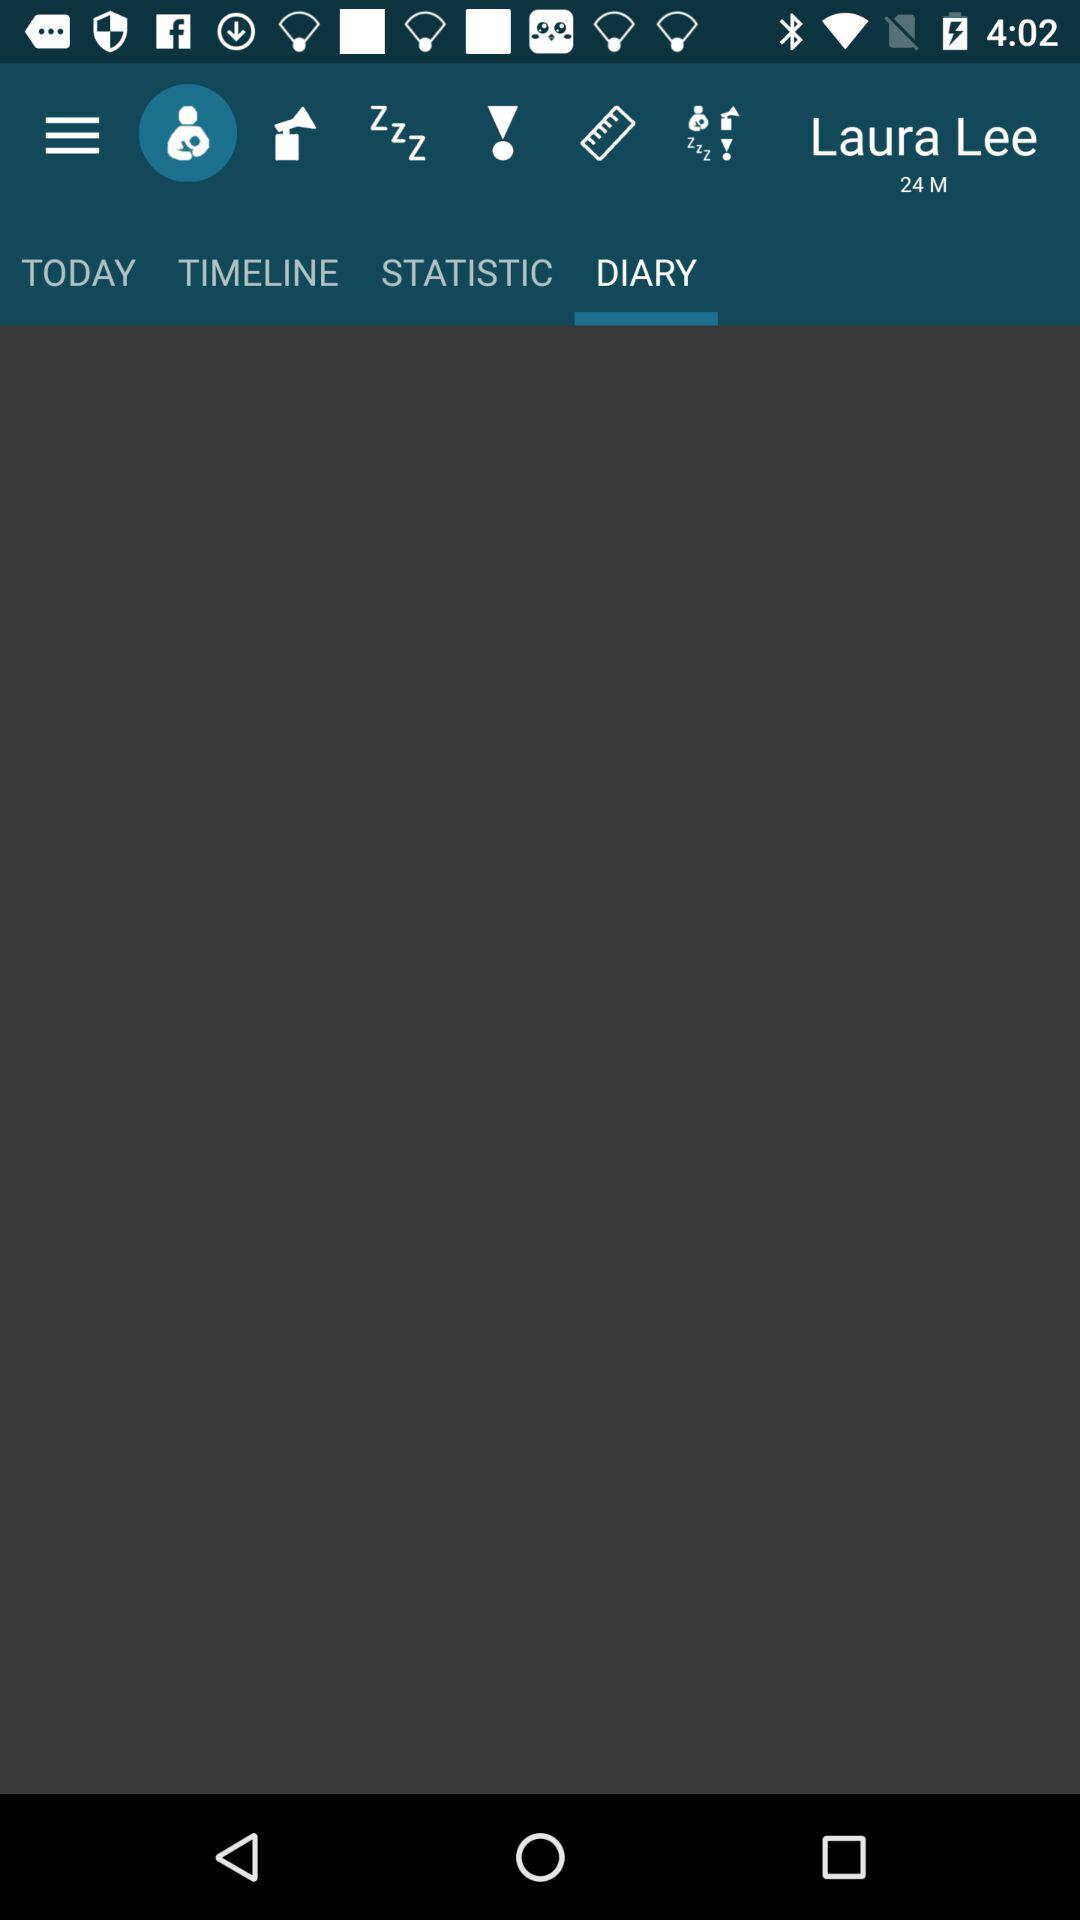What is the name of the user? The name of the user is Laura Lee. 